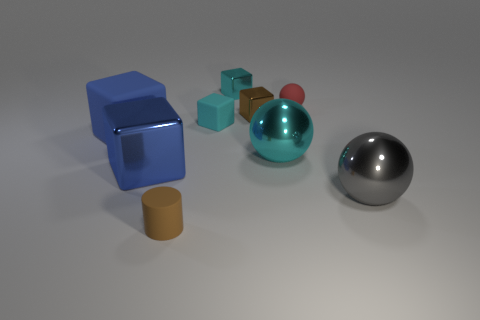Subtract all brown metal blocks. How many blocks are left? 4 Subtract all cyan balls. How many balls are left? 2 Subtract all balls. How many objects are left? 6 Add 1 blue matte cubes. How many blue matte cubes are left? 2 Add 6 big blue rubber blocks. How many big blue rubber blocks exist? 7 Subtract 0 gray cylinders. How many objects are left? 9 Subtract 3 cubes. How many cubes are left? 2 Subtract all yellow cylinders. Subtract all cyan spheres. How many cylinders are left? 1 Subtract all gray cylinders. How many gray spheres are left? 1 Subtract all small purple objects. Subtract all big blue metal objects. How many objects are left? 8 